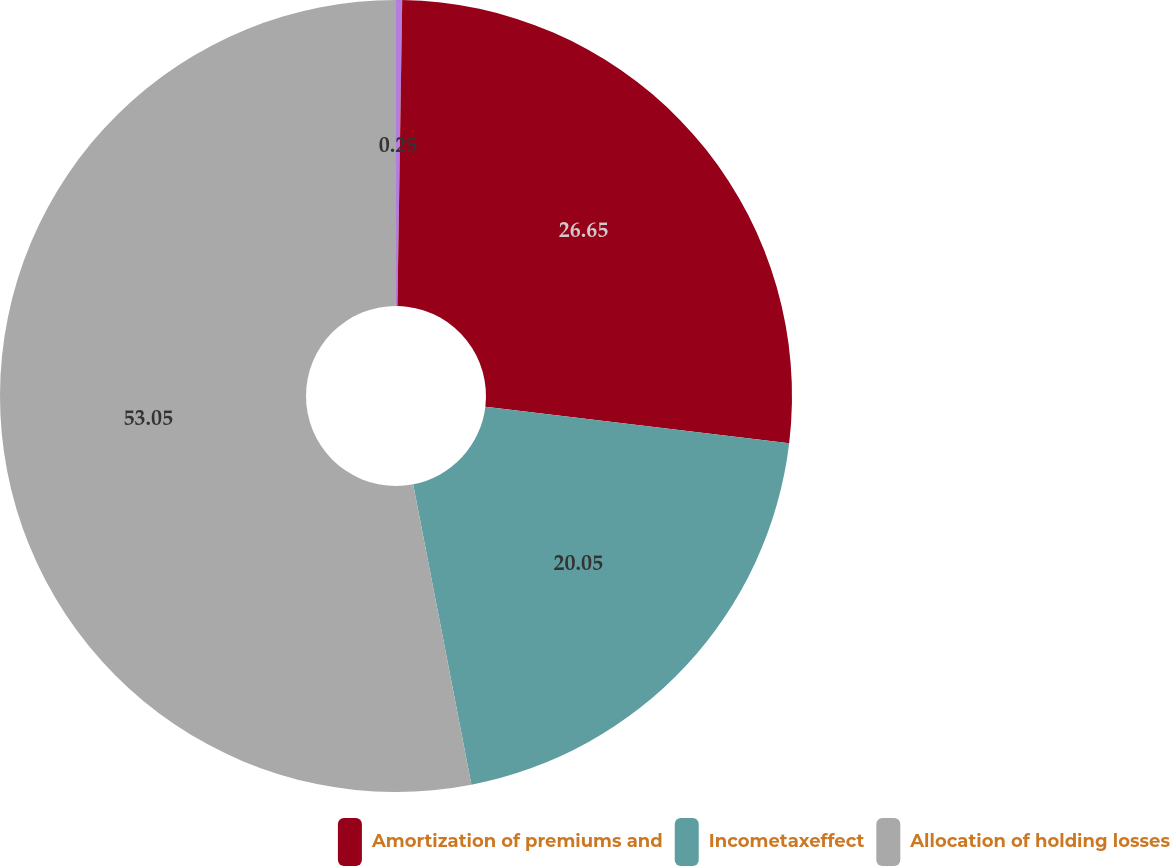Convert chart. <chart><loc_0><loc_0><loc_500><loc_500><pie_chart><ecel><fcel>Amortization of premiums and<fcel>Incometaxeffect<fcel>Allocation of holding losses<nl><fcel>0.25%<fcel>26.65%<fcel>20.05%<fcel>53.05%<nl></chart> 